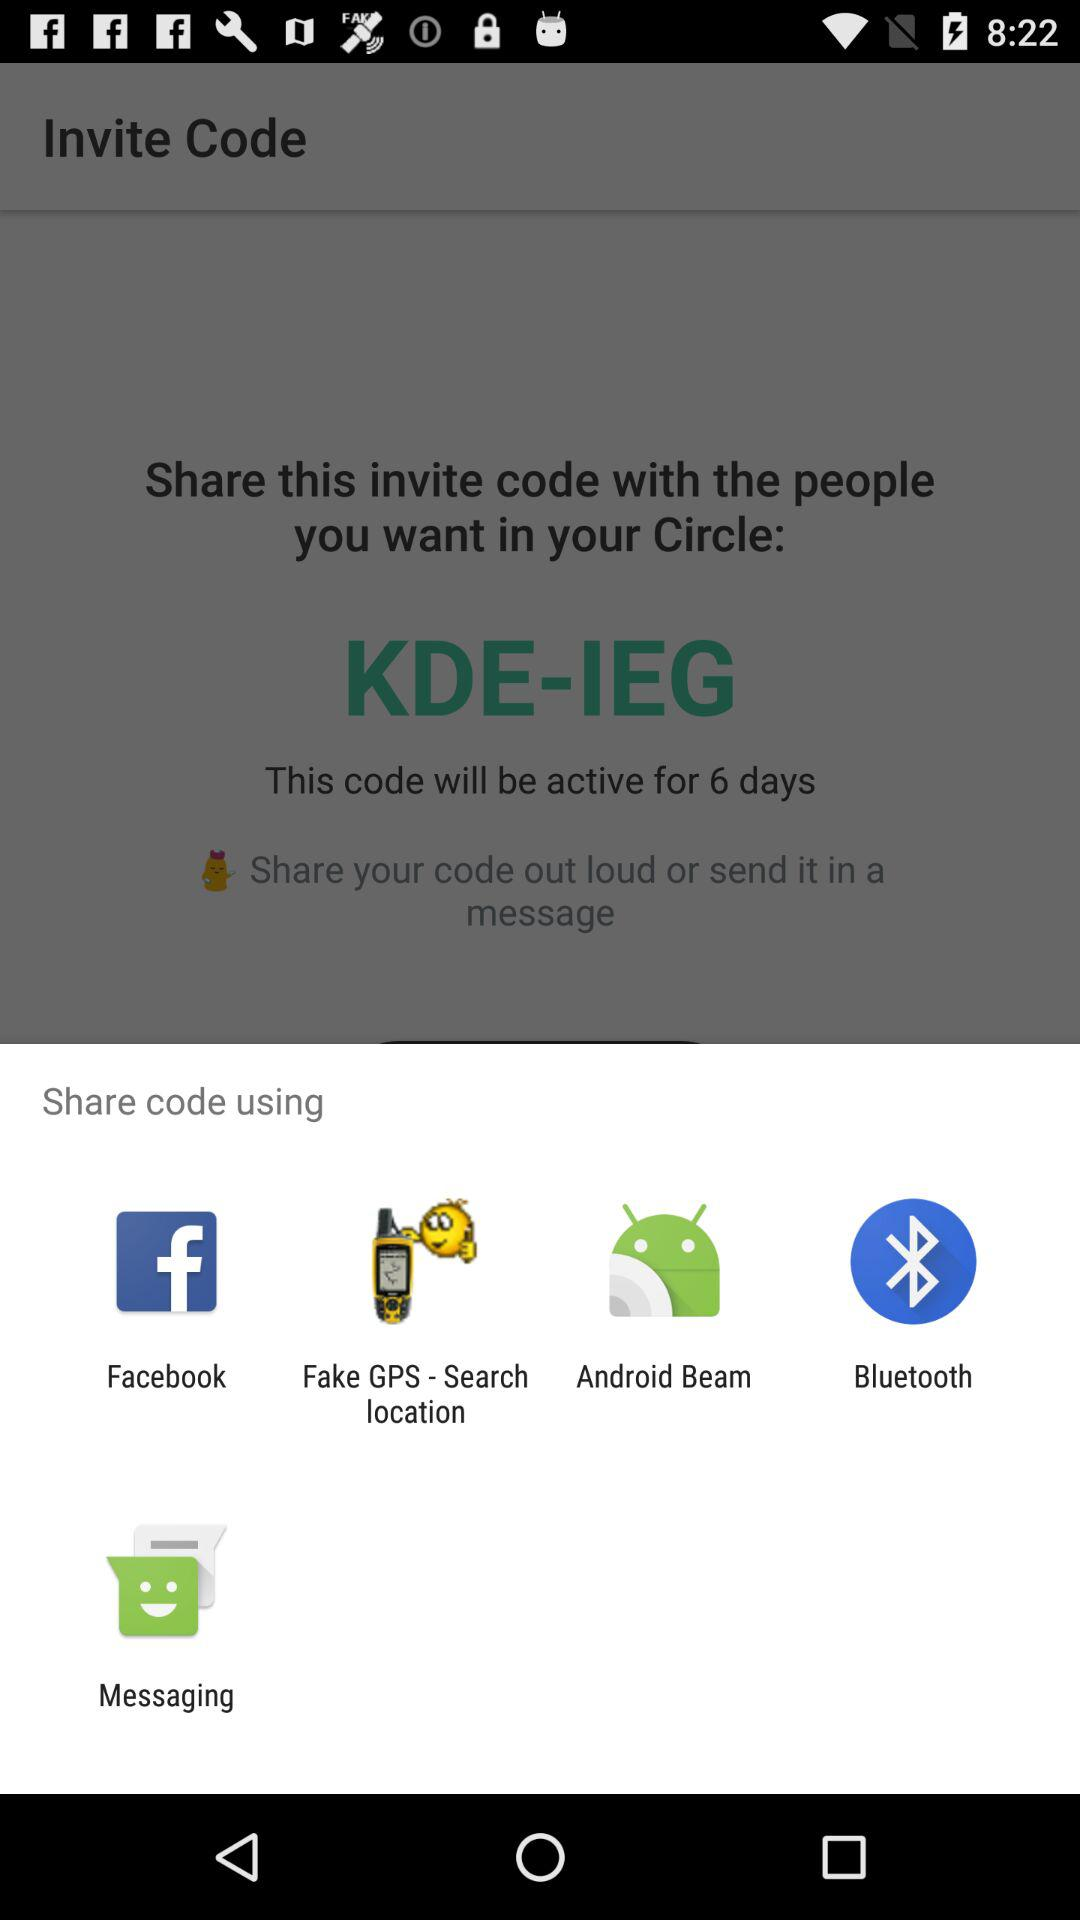What is the active time period of the code? The active time period of the code is 6 days. 